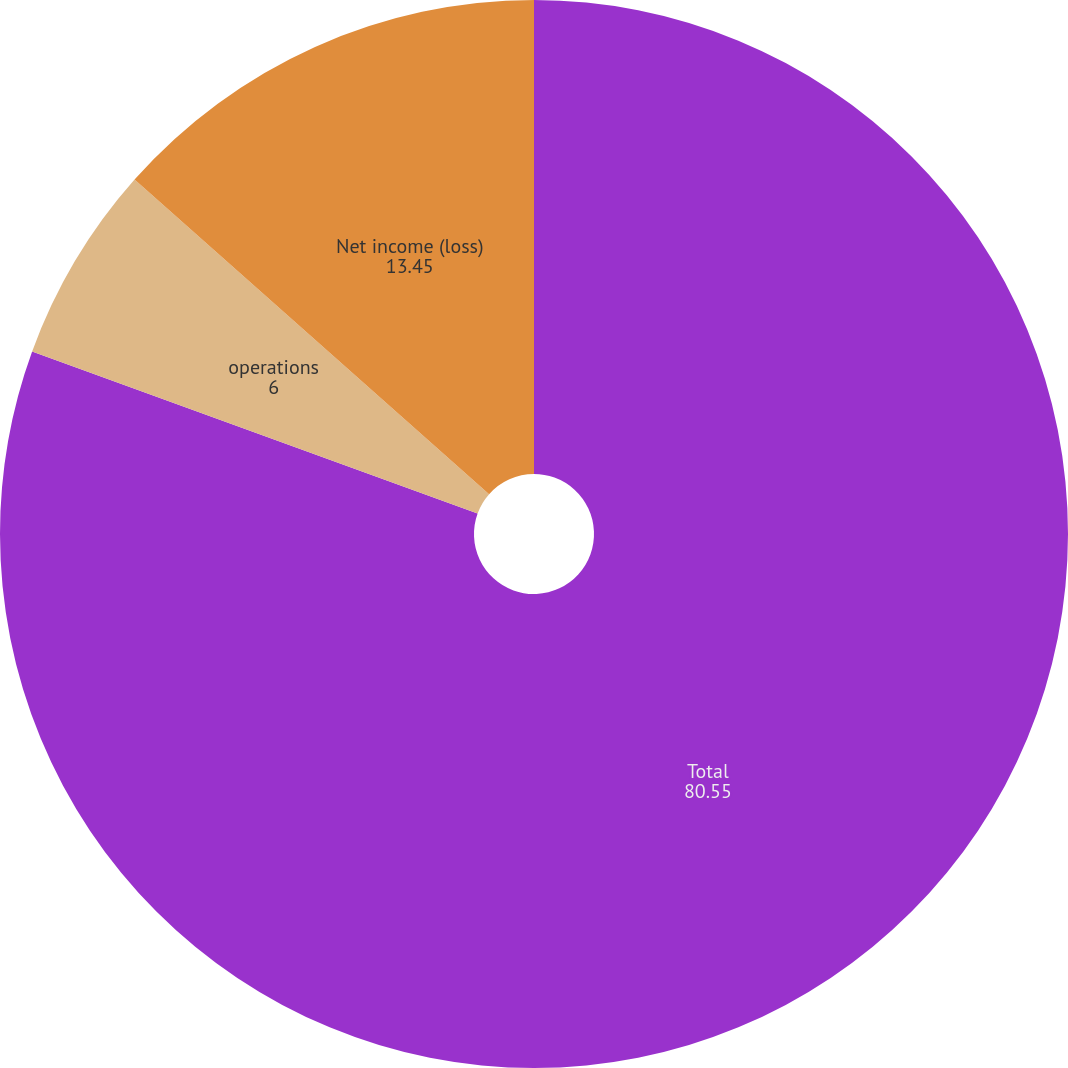<chart> <loc_0><loc_0><loc_500><loc_500><pie_chart><fcel>Total<fcel>operations<fcel>Net income (loss)<nl><fcel>80.55%<fcel>6.0%<fcel>13.45%<nl></chart> 